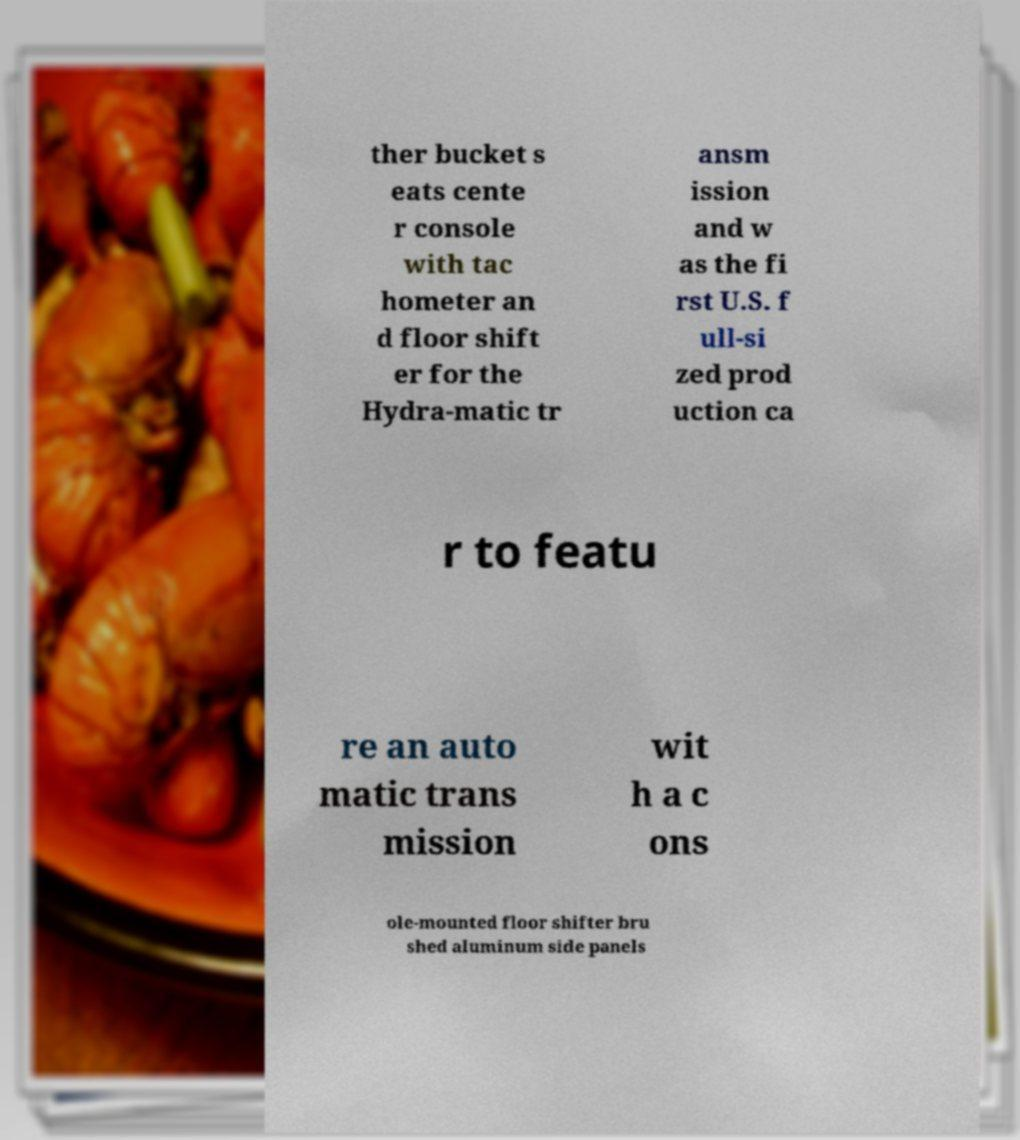Can you read and provide the text displayed in the image?This photo seems to have some interesting text. Can you extract and type it out for me? ther bucket s eats cente r console with tac hometer an d floor shift er for the Hydra-matic tr ansm ission and w as the fi rst U.S. f ull-si zed prod uction ca r to featu re an auto matic trans mission wit h a c ons ole-mounted floor shifter bru shed aluminum side panels 